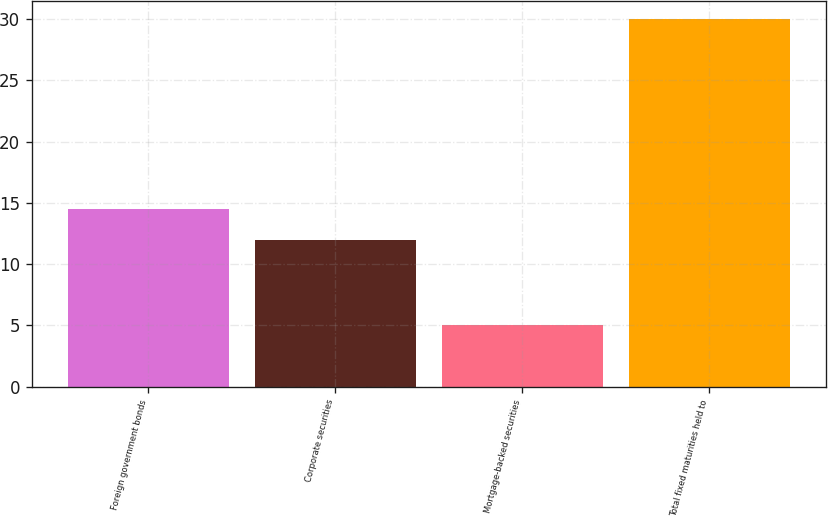Convert chart. <chart><loc_0><loc_0><loc_500><loc_500><bar_chart><fcel>Foreign government bonds<fcel>Corporate securities<fcel>Mortgage-backed securities<fcel>Total fixed maturities held to<nl><fcel>14.5<fcel>12<fcel>5<fcel>30<nl></chart> 